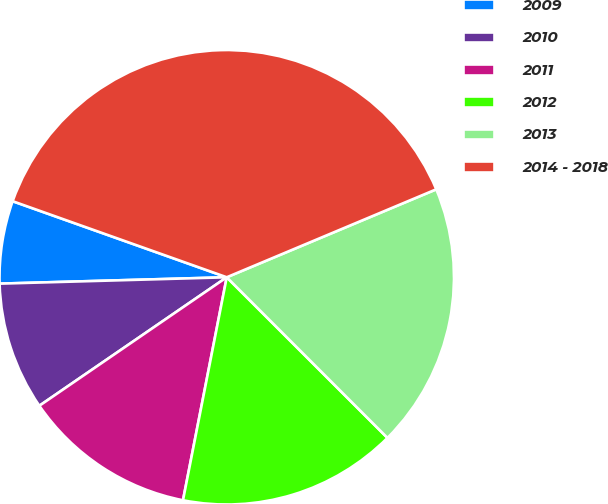Convert chart. <chart><loc_0><loc_0><loc_500><loc_500><pie_chart><fcel>2009<fcel>2010<fcel>2011<fcel>2012<fcel>2013<fcel>2014 - 2018<nl><fcel>5.88%<fcel>9.12%<fcel>12.35%<fcel>15.59%<fcel>18.82%<fcel>38.24%<nl></chart> 